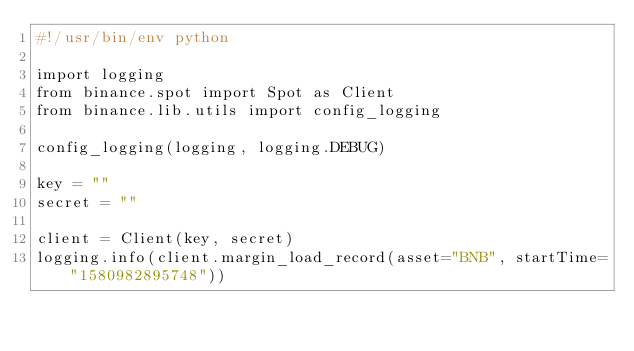<code> <loc_0><loc_0><loc_500><loc_500><_Python_>#!/usr/bin/env python

import logging
from binance.spot import Spot as Client
from binance.lib.utils import config_logging

config_logging(logging, logging.DEBUG)

key = ""
secret = ""

client = Client(key, secret)
logging.info(client.margin_load_record(asset="BNB", startTime="1580982895748"))
</code> 